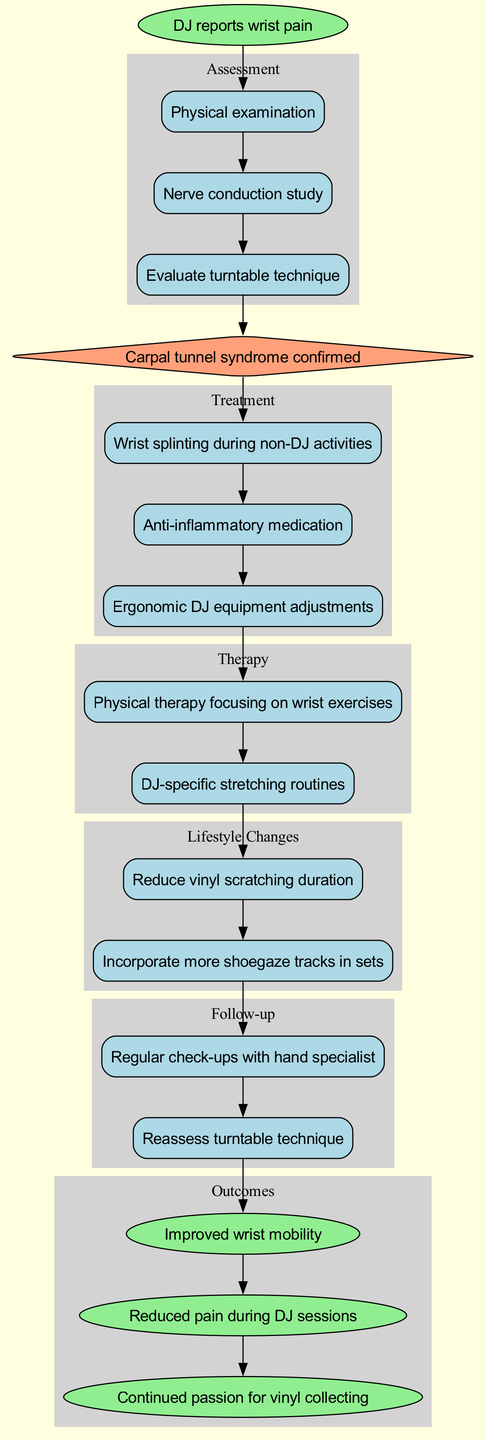What is the starting point of the clinical pathway? The starting point is represented by the first node in the diagram, which states "DJ reports wrist pain." This is the initial situation that triggers the entire process.
Answer: DJ reports wrist pain How many assessments are included in the pathway? The pathway includes three assessment nodes: "Physical examination," "Nerve conduction study," and "Evaluate turntable technique." Counting these gives a total of three assessments.
Answer: 3 What is the diagnosis confirmed after the assessments? The node directly following the assessment nodes is labeled "Carpal tunnel syndrome confirmed," indicating the diagnosis reached after evaluating the assessments.
Answer: Carpal tunnel syndrome confirmed What type of treatment is suggested for non-DJ activities? One of the treatment nodes is "Wrist splinting during non-DJ activities." This node describes a specific treatment that focuses on wrist support when not performing as a DJ.
Answer: Wrist splinting during non-DJ activities How many follow-up actions are recommended? There are two follow-up actions mentioned: "Regular check-ups with hand specialist" and "Reassess turntable technique." Counting these gives a total of two follow-up actions.
Answer: 2 What are the expected outcomes related to wrist mobility? One of the outcomes listed is "Improved wrist mobility." This indicates a specific positive result expected from the interventions in the pathway related to wrist function.
Answer: Improved wrist mobility What lifestyle change involves the duration of vinyl scratching? One of the lifestyle changes indicated is "Reduce vinyl scratching duration." This specifies a change in behavior regarding the position of performing DJs.
Answer: Reduce vinyl scratching duration Which type of therapy focuses on wrist exercises? The therapy node labeled "Physical therapy focusing on wrist exercises" indicates a specific type of therapy aimed at improving wrist condition through exercises.
Answer: Physical therapy focusing on wrist exercises What is the outcome related to pain during DJ sessions? The outcome "Reduced pain during DJ sessions" specifies a direct benefit expected from the treatments and therapies outlined in the pathway concerning pain management.
Answer: Reduced pain during DJ sessions 